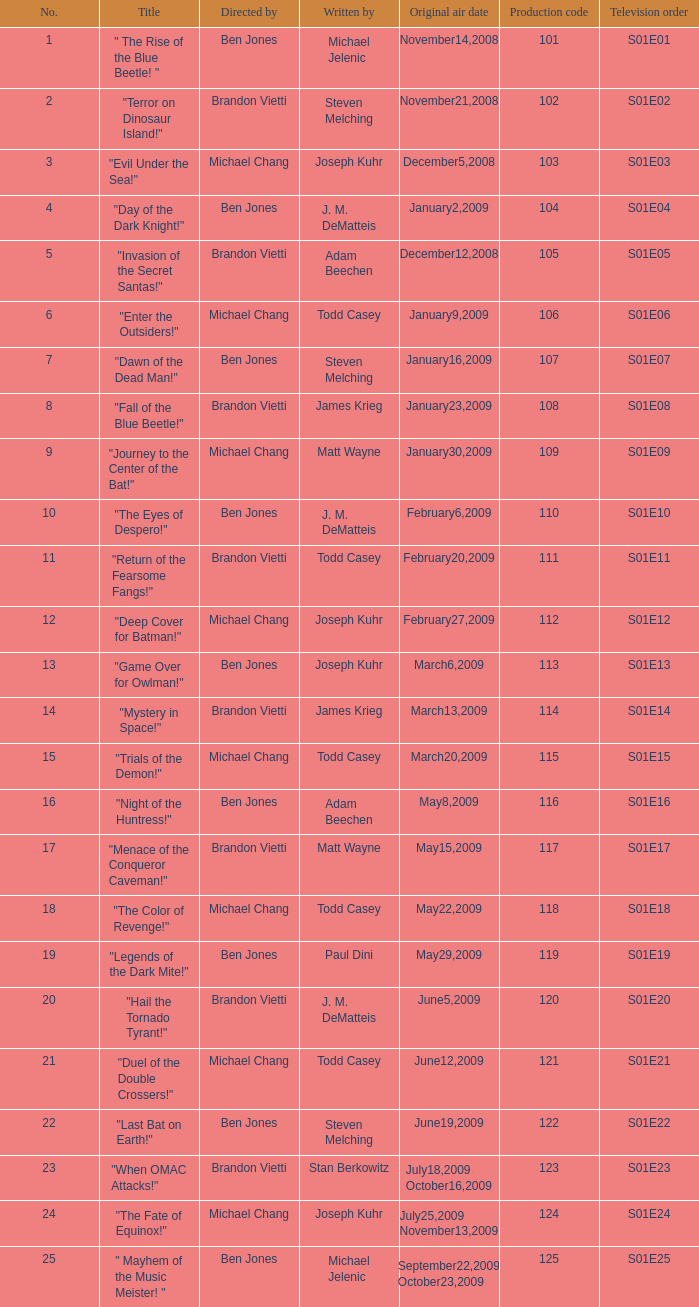Who wrote s01e06 Todd Casey. 